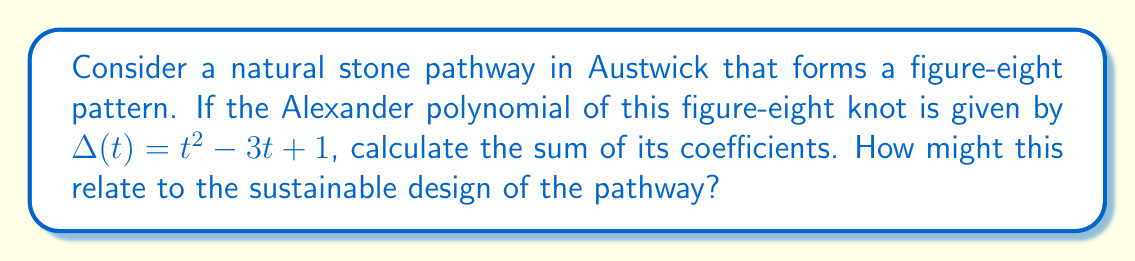Could you help me with this problem? Let's approach this step-by-step:

1) The Alexander polynomial of the figure-eight knot is given as:
   $$\Delta(t) = t^2 - 3t + 1$$

2) To find the sum of the coefficients, we need to identify each coefficient:
   - The coefficient of $t^2$ is 1
   - The coefficient of $t$ is -3
   - The constant term (coefficient of $t^0$) is 1

3) Now, let's sum these coefficients:
   $$1 + (-3) + 1 = -1$$

4) The sum of the coefficients of the Alexander polynomial is -1.

5) Relevance to sustainable pathway design:
   - The figure-eight knot represents a compact, efficient path layout.
   - The sum of coefficients (-1) being non-zero indicates the non-triviality of the knot, suggesting a complex but interesting path design.
   - In sustainable landscaping, this could translate to a path that maximizes coverage while minimizing material use.
   - The balanced nature of the polynomial (positive and negative terms) might inspire a design that balances areas of stone paving with natural ground cover, promoting biodiversity.
Answer: -1 